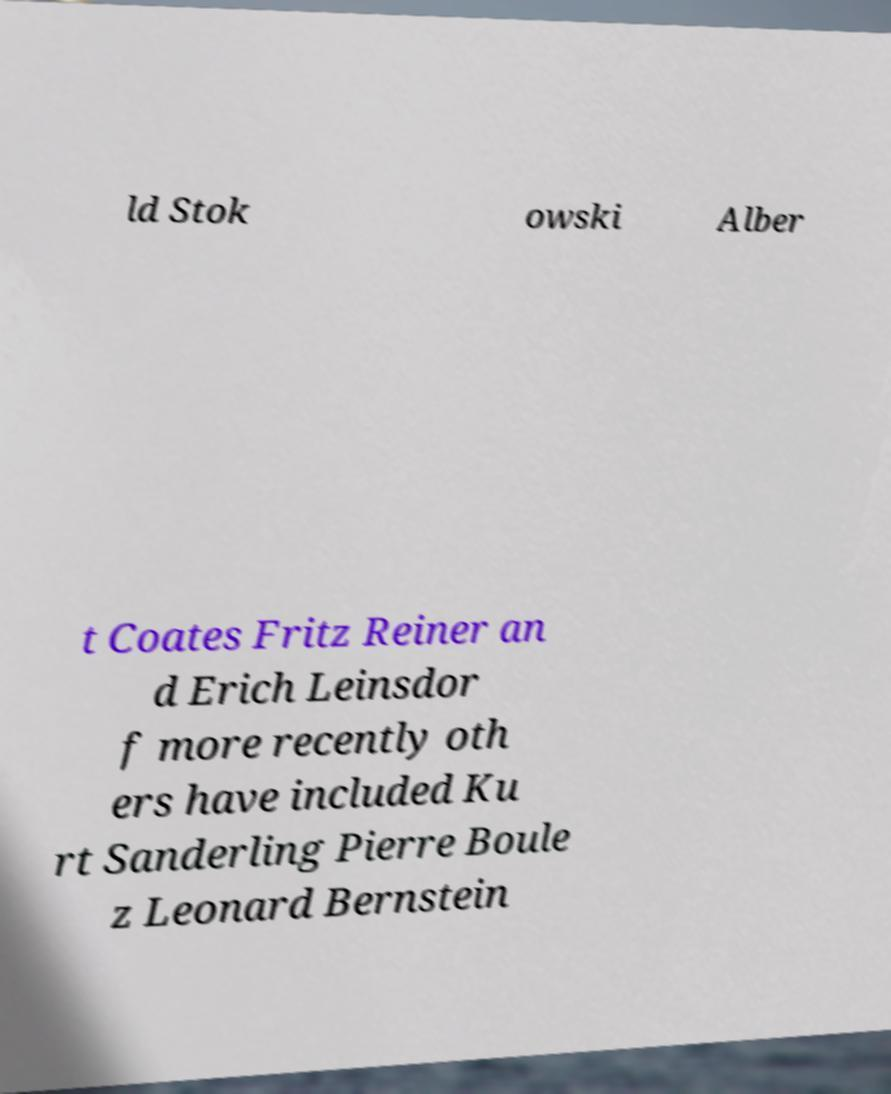Can you read and provide the text displayed in the image?This photo seems to have some interesting text. Can you extract and type it out for me? ld Stok owski Alber t Coates Fritz Reiner an d Erich Leinsdor f more recently oth ers have included Ku rt Sanderling Pierre Boule z Leonard Bernstein 